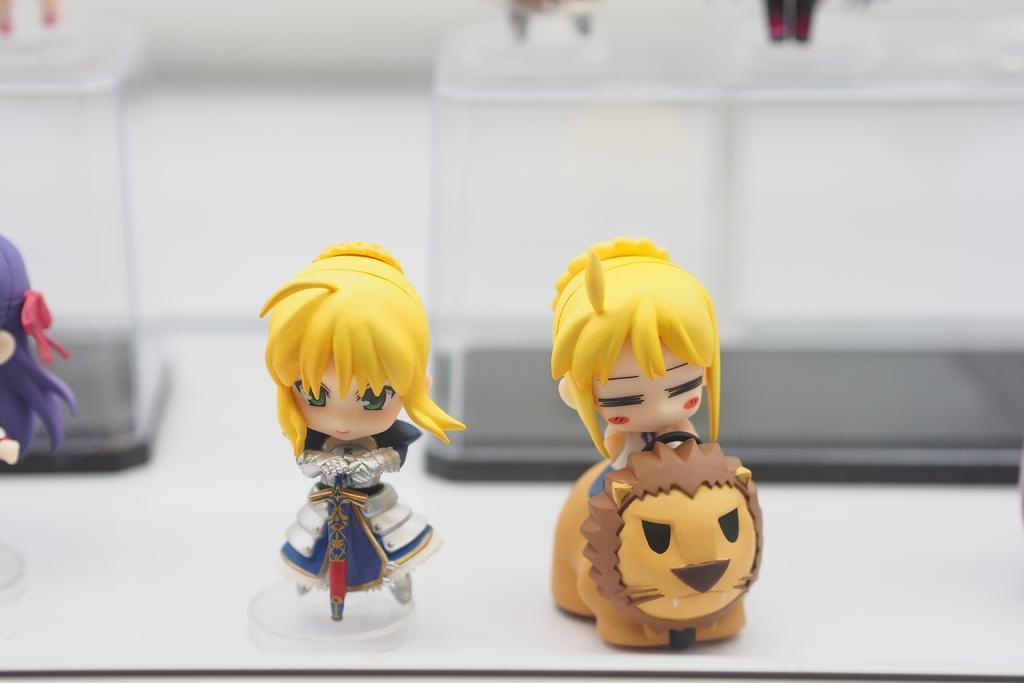Describe this image in one or two sentences. In this picture I can see 4 toys on the white color surface and I see that it is a bit blurry in the background. 